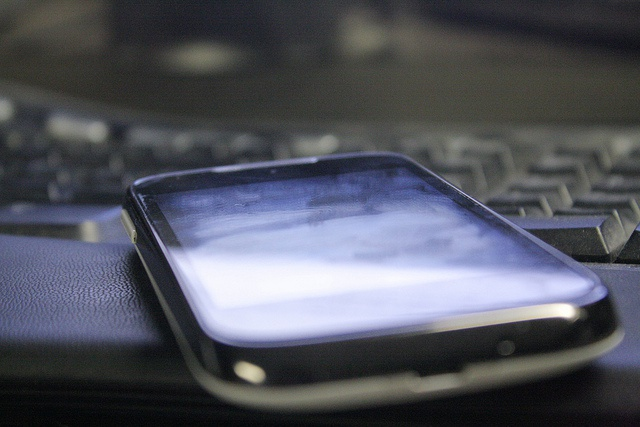Describe the objects in this image and their specific colors. I can see cell phone in gray, black, lavender, and darkgray tones and keyboard in gray, black, and purple tones in this image. 